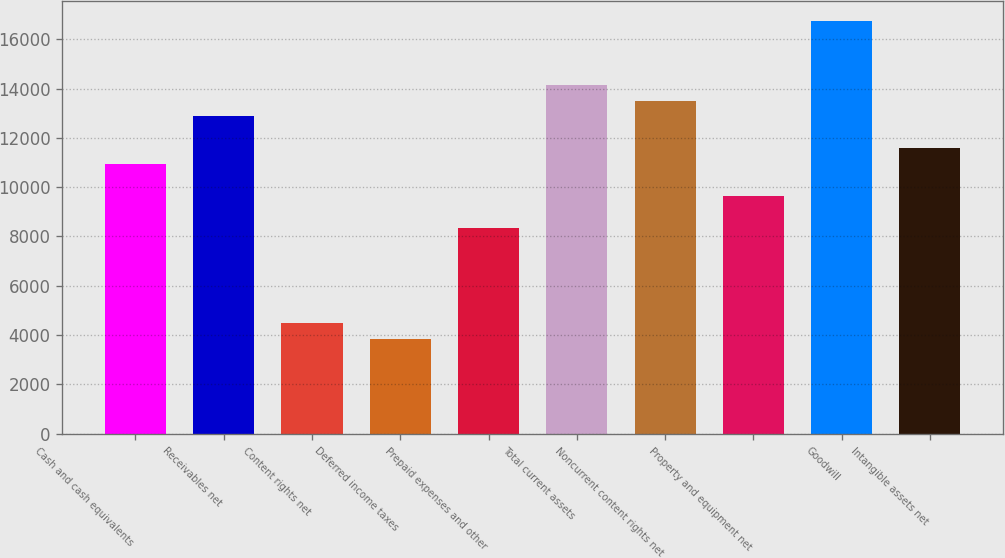Convert chart to OTSL. <chart><loc_0><loc_0><loc_500><loc_500><bar_chart><fcel>Cash and cash equivalents<fcel>Receivables net<fcel>Content rights net<fcel>Deferred income taxes<fcel>Prepaid expenses and other<fcel>Total current assets<fcel>Noncurrent content rights net<fcel>Property and equipment net<fcel>Goodwill<fcel>Intangible assets net<nl><fcel>10937.1<fcel>12867<fcel>4504.1<fcel>3860.8<fcel>8363.9<fcel>14153.6<fcel>13510.3<fcel>9650.5<fcel>16726.8<fcel>11580.4<nl></chart> 